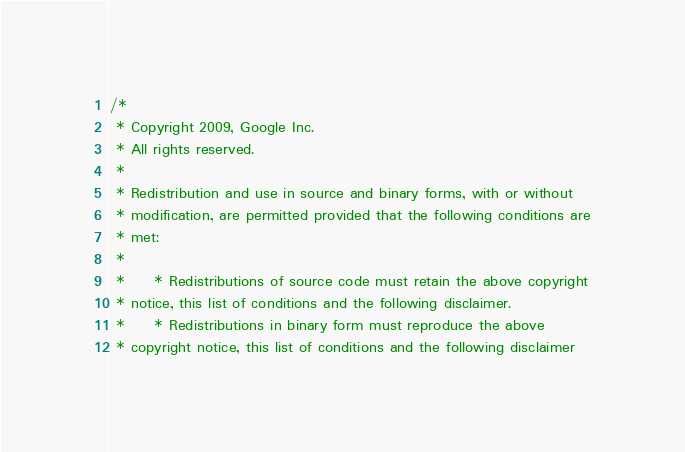<code> <loc_0><loc_0><loc_500><loc_500><_C++_>/*
 * Copyright 2009, Google Inc.
 * All rights reserved.
 *
 * Redistribution and use in source and binary forms, with or without
 * modification, are permitted provided that the following conditions are
 * met:
 *
 *     * Redistributions of source code must retain the above copyright
 * notice, this list of conditions and the following disclaimer.
 *     * Redistributions in binary form must reproduce the above
 * copyright notice, this list of conditions and the following disclaimer</code> 